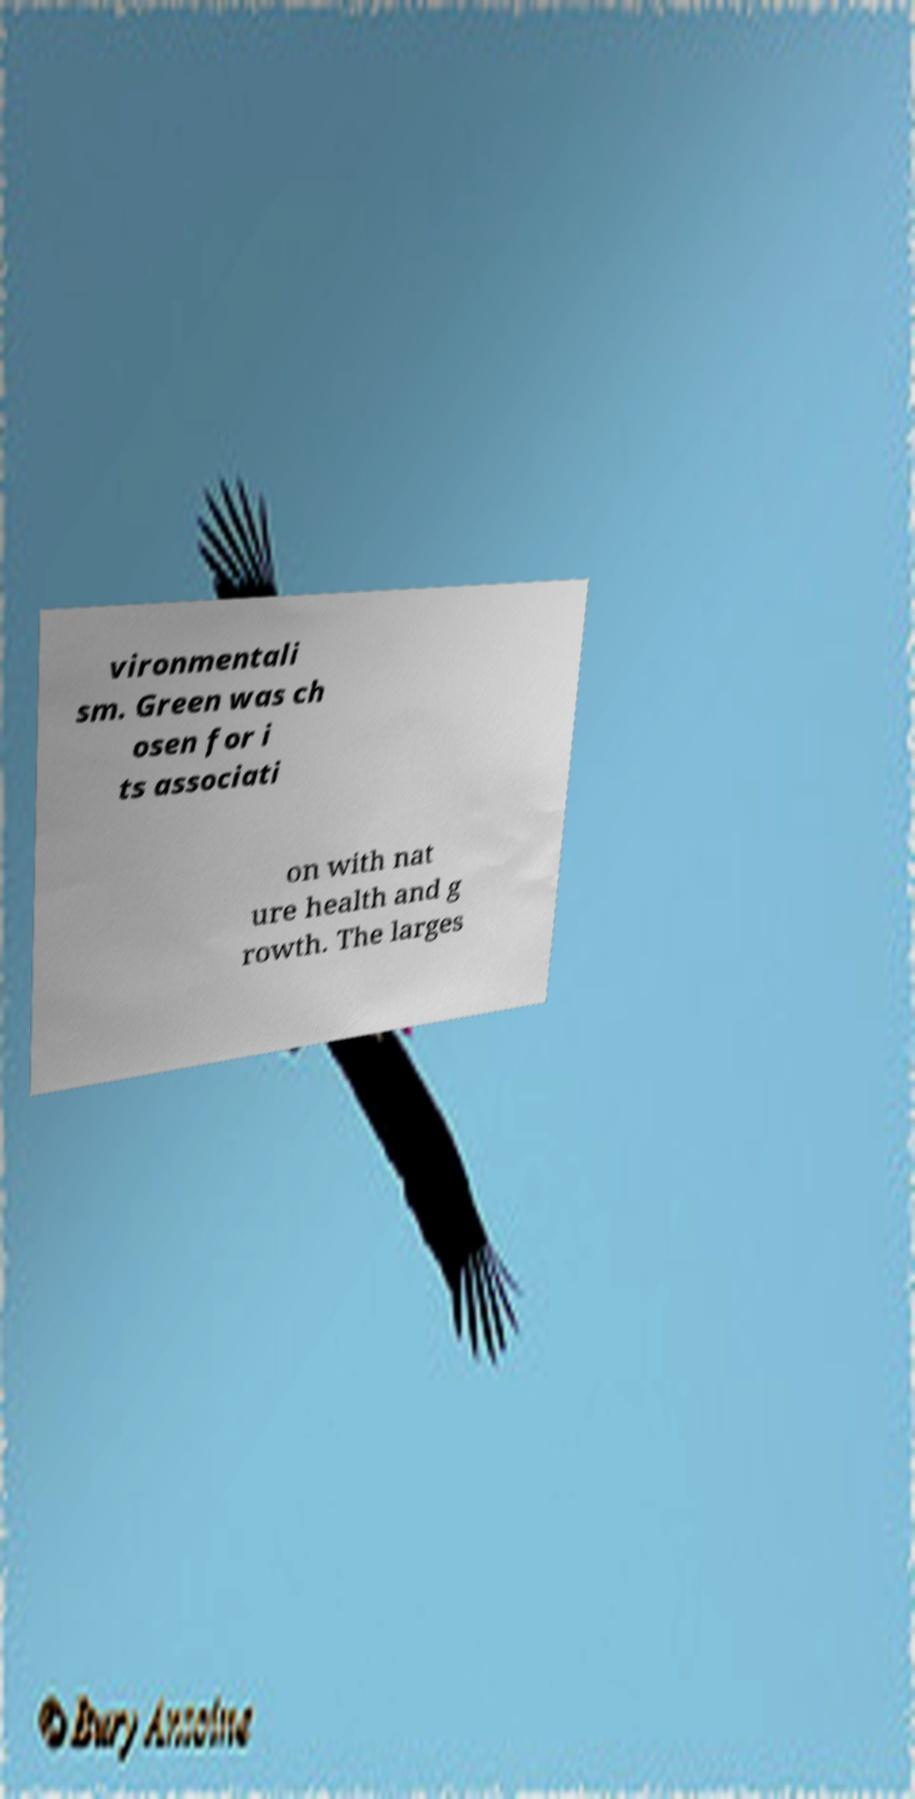Please identify and transcribe the text found in this image. vironmentali sm. Green was ch osen for i ts associati on with nat ure health and g rowth. The larges 